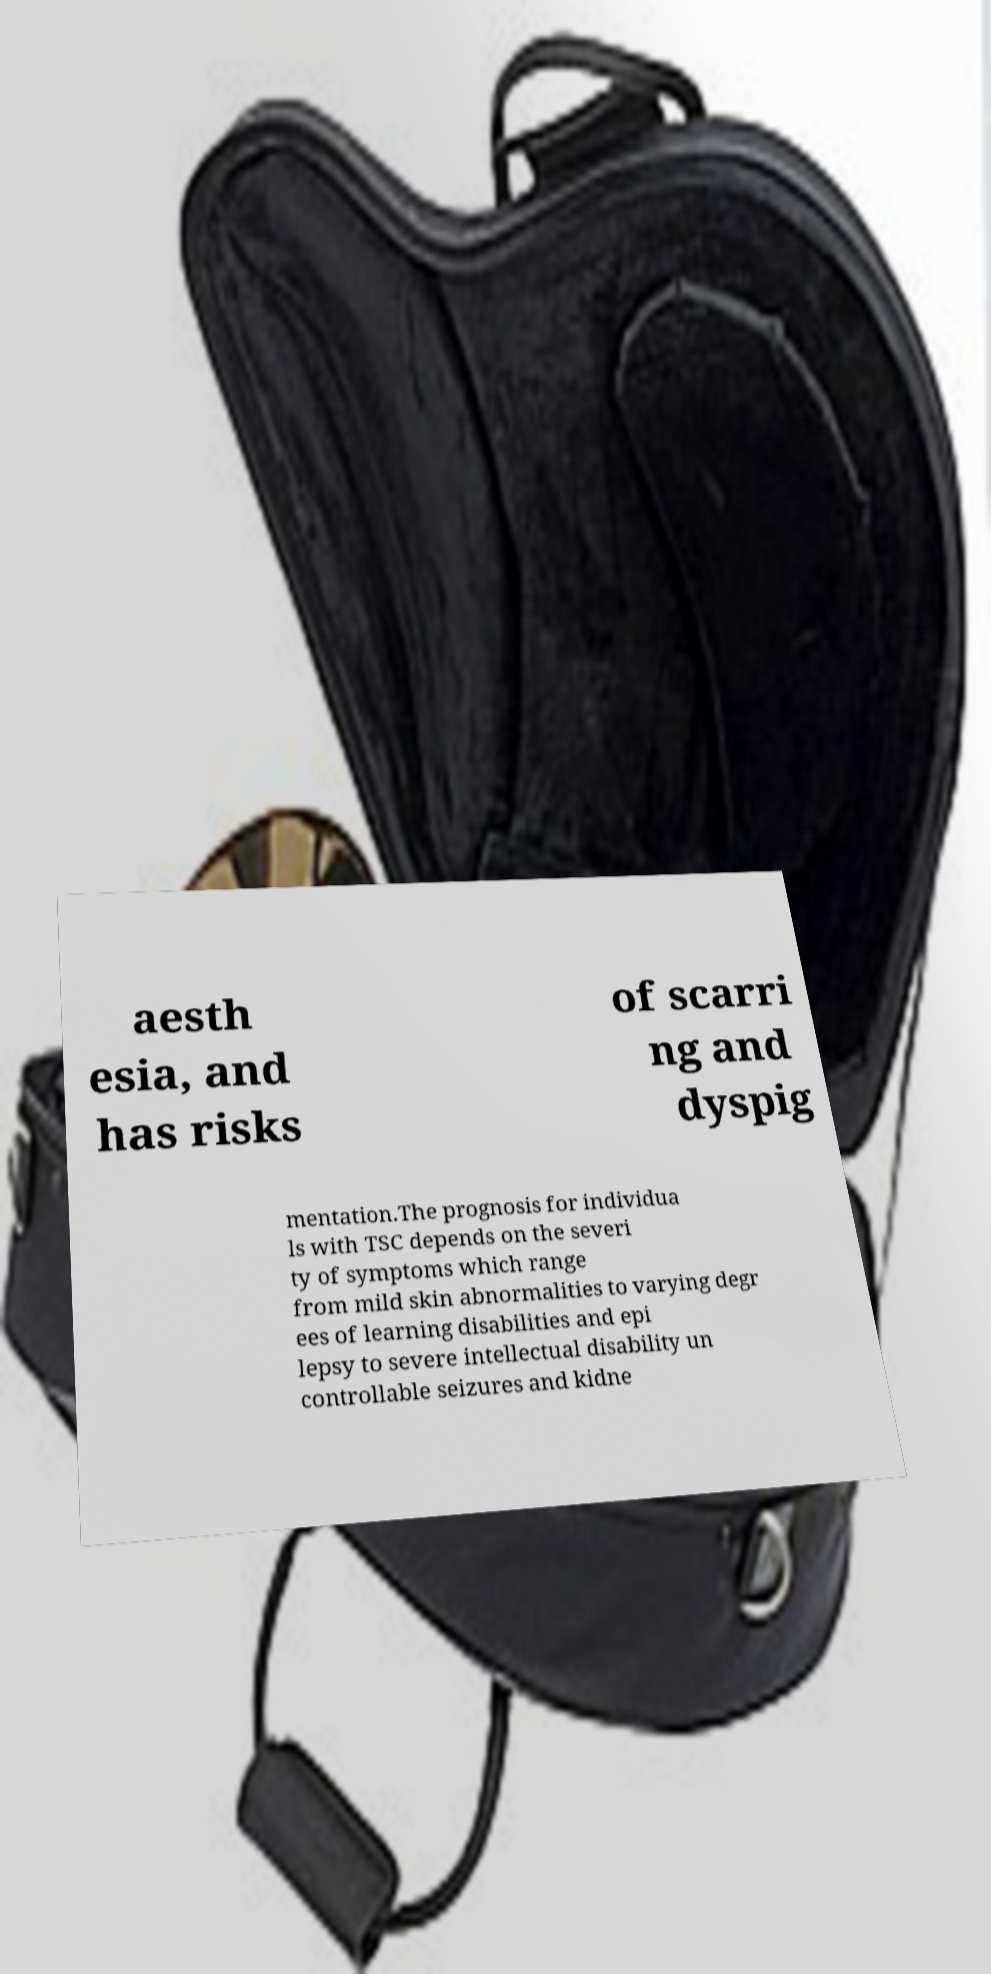Could you extract and type out the text from this image? aesth esia, and has risks of scarri ng and dyspig mentation.The prognosis for individua ls with TSC depends on the severi ty of symptoms which range from mild skin abnormalities to varying degr ees of learning disabilities and epi lepsy to severe intellectual disability un controllable seizures and kidne 